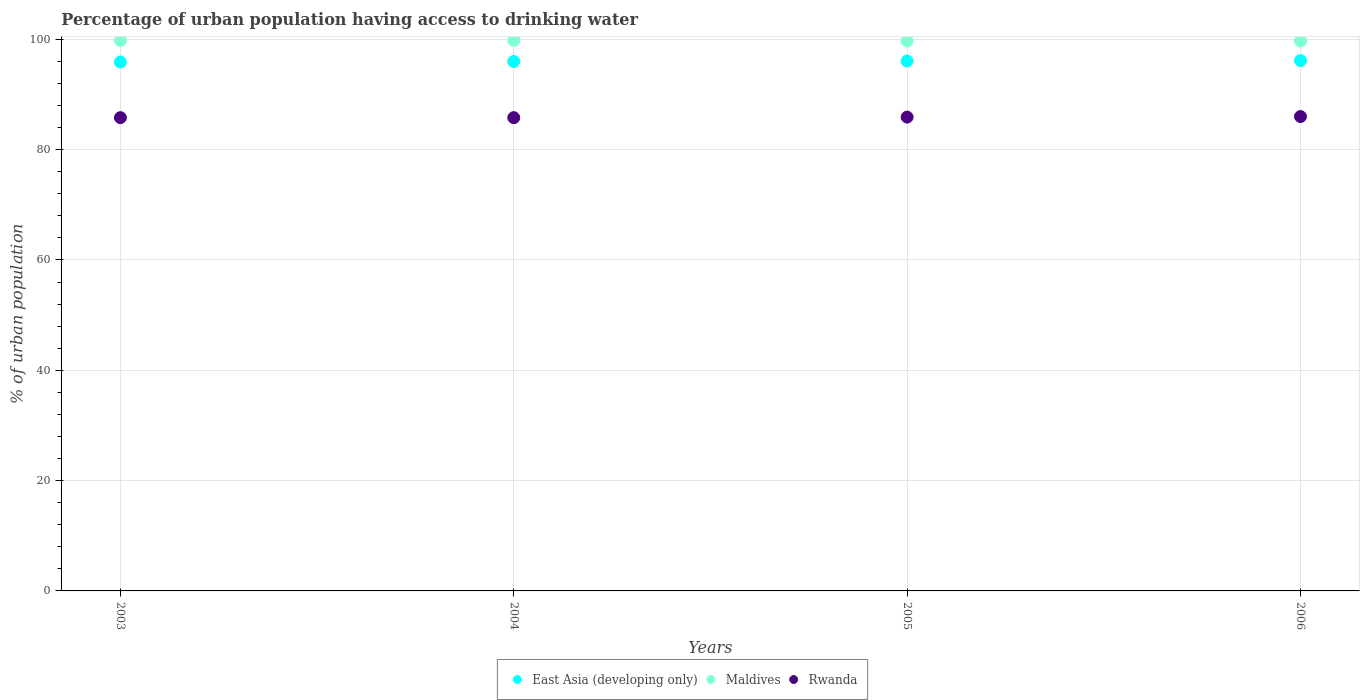What is the percentage of urban population having access to drinking water in Maldives in 2005?
Your answer should be compact. 99.7. Across all years, what is the maximum percentage of urban population having access to drinking water in Maldives?
Your response must be concise. 99.8. Across all years, what is the minimum percentage of urban population having access to drinking water in East Asia (developing only)?
Give a very brief answer. 95.9. In which year was the percentage of urban population having access to drinking water in East Asia (developing only) minimum?
Your response must be concise. 2003. What is the total percentage of urban population having access to drinking water in East Asia (developing only) in the graph?
Make the answer very short. 384.1. What is the difference between the percentage of urban population having access to drinking water in Maldives in 2004 and that in 2006?
Provide a succinct answer. 0.1. What is the difference between the percentage of urban population having access to drinking water in Rwanda in 2003 and the percentage of urban population having access to drinking water in Maldives in 2005?
Offer a terse response. -13.9. What is the average percentage of urban population having access to drinking water in Rwanda per year?
Offer a terse response. 85.88. In the year 2003, what is the difference between the percentage of urban population having access to drinking water in East Asia (developing only) and percentage of urban population having access to drinking water in Maldives?
Your response must be concise. -3.9. In how many years, is the percentage of urban population having access to drinking water in Rwanda greater than 40 %?
Offer a very short reply. 4. What is the ratio of the percentage of urban population having access to drinking water in Rwanda in 2003 to that in 2004?
Offer a very short reply. 1. Is the difference between the percentage of urban population having access to drinking water in East Asia (developing only) in 2003 and 2006 greater than the difference between the percentage of urban population having access to drinking water in Maldives in 2003 and 2006?
Provide a succinct answer. No. What is the difference between the highest and the second highest percentage of urban population having access to drinking water in East Asia (developing only)?
Provide a short and direct response. 0.08. What is the difference between the highest and the lowest percentage of urban population having access to drinking water in Rwanda?
Give a very brief answer. 0.2. Is the sum of the percentage of urban population having access to drinking water in East Asia (developing only) in 2005 and 2006 greater than the maximum percentage of urban population having access to drinking water in Maldives across all years?
Your response must be concise. Yes. Does the percentage of urban population having access to drinking water in Rwanda monotonically increase over the years?
Your answer should be compact. No. Is the percentage of urban population having access to drinking water in Maldives strictly greater than the percentage of urban population having access to drinking water in East Asia (developing only) over the years?
Keep it short and to the point. Yes. How many dotlines are there?
Offer a very short reply. 3. What is the difference between two consecutive major ticks on the Y-axis?
Your response must be concise. 20. Does the graph contain any zero values?
Your answer should be very brief. No. Where does the legend appear in the graph?
Offer a very short reply. Bottom center. What is the title of the graph?
Your answer should be very brief. Percentage of urban population having access to drinking water. Does "Venezuela" appear as one of the legend labels in the graph?
Provide a succinct answer. No. What is the label or title of the X-axis?
Give a very brief answer. Years. What is the label or title of the Y-axis?
Provide a short and direct response. % of urban population. What is the % of urban population of East Asia (developing only) in 2003?
Ensure brevity in your answer.  95.9. What is the % of urban population of Maldives in 2003?
Offer a terse response. 99.8. What is the % of urban population of Rwanda in 2003?
Offer a very short reply. 85.8. What is the % of urban population in East Asia (developing only) in 2004?
Keep it short and to the point. 95.98. What is the % of urban population in Maldives in 2004?
Provide a succinct answer. 99.8. What is the % of urban population in Rwanda in 2004?
Your answer should be very brief. 85.8. What is the % of urban population of East Asia (developing only) in 2005?
Your response must be concise. 96.07. What is the % of urban population of Maldives in 2005?
Your answer should be compact. 99.7. What is the % of urban population of Rwanda in 2005?
Give a very brief answer. 85.9. What is the % of urban population in East Asia (developing only) in 2006?
Give a very brief answer. 96.15. What is the % of urban population in Maldives in 2006?
Offer a very short reply. 99.7. Across all years, what is the maximum % of urban population in East Asia (developing only)?
Provide a succinct answer. 96.15. Across all years, what is the maximum % of urban population of Maldives?
Give a very brief answer. 99.8. Across all years, what is the maximum % of urban population of Rwanda?
Give a very brief answer. 86. Across all years, what is the minimum % of urban population of East Asia (developing only)?
Give a very brief answer. 95.9. Across all years, what is the minimum % of urban population in Maldives?
Offer a very short reply. 99.7. Across all years, what is the minimum % of urban population of Rwanda?
Give a very brief answer. 85.8. What is the total % of urban population in East Asia (developing only) in the graph?
Give a very brief answer. 384.1. What is the total % of urban population of Maldives in the graph?
Provide a short and direct response. 399. What is the total % of urban population in Rwanda in the graph?
Give a very brief answer. 343.5. What is the difference between the % of urban population of East Asia (developing only) in 2003 and that in 2004?
Your answer should be very brief. -0.09. What is the difference between the % of urban population in Maldives in 2003 and that in 2004?
Ensure brevity in your answer.  0. What is the difference between the % of urban population of Rwanda in 2003 and that in 2004?
Offer a terse response. 0. What is the difference between the % of urban population of East Asia (developing only) in 2003 and that in 2005?
Ensure brevity in your answer.  -0.17. What is the difference between the % of urban population in Rwanda in 2003 and that in 2005?
Your response must be concise. -0.1. What is the difference between the % of urban population of East Asia (developing only) in 2003 and that in 2006?
Provide a succinct answer. -0.25. What is the difference between the % of urban population in Rwanda in 2003 and that in 2006?
Ensure brevity in your answer.  -0.2. What is the difference between the % of urban population in East Asia (developing only) in 2004 and that in 2005?
Your response must be concise. -0.08. What is the difference between the % of urban population of Rwanda in 2004 and that in 2005?
Your response must be concise. -0.1. What is the difference between the % of urban population of East Asia (developing only) in 2004 and that in 2006?
Your answer should be compact. -0.16. What is the difference between the % of urban population of East Asia (developing only) in 2005 and that in 2006?
Provide a short and direct response. -0.08. What is the difference between the % of urban population of Maldives in 2005 and that in 2006?
Offer a very short reply. 0. What is the difference between the % of urban population of East Asia (developing only) in 2003 and the % of urban population of Maldives in 2004?
Ensure brevity in your answer.  -3.9. What is the difference between the % of urban population of East Asia (developing only) in 2003 and the % of urban population of Rwanda in 2004?
Give a very brief answer. 10.1. What is the difference between the % of urban population in East Asia (developing only) in 2003 and the % of urban population in Maldives in 2005?
Make the answer very short. -3.8. What is the difference between the % of urban population in East Asia (developing only) in 2003 and the % of urban population in Rwanda in 2005?
Keep it short and to the point. 10. What is the difference between the % of urban population in East Asia (developing only) in 2003 and the % of urban population in Maldives in 2006?
Give a very brief answer. -3.8. What is the difference between the % of urban population of East Asia (developing only) in 2003 and the % of urban population of Rwanda in 2006?
Your response must be concise. 9.9. What is the difference between the % of urban population of Maldives in 2003 and the % of urban population of Rwanda in 2006?
Offer a terse response. 13.8. What is the difference between the % of urban population in East Asia (developing only) in 2004 and the % of urban population in Maldives in 2005?
Your response must be concise. -3.72. What is the difference between the % of urban population in East Asia (developing only) in 2004 and the % of urban population in Rwanda in 2005?
Offer a terse response. 10.08. What is the difference between the % of urban population of East Asia (developing only) in 2004 and the % of urban population of Maldives in 2006?
Offer a terse response. -3.72. What is the difference between the % of urban population of East Asia (developing only) in 2004 and the % of urban population of Rwanda in 2006?
Make the answer very short. 9.98. What is the difference between the % of urban population of East Asia (developing only) in 2005 and the % of urban population of Maldives in 2006?
Ensure brevity in your answer.  -3.63. What is the difference between the % of urban population in East Asia (developing only) in 2005 and the % of urban population in Rwanda in 2006?
Give a very brief answer. 10.07. What is the difference between the % of urban population of Maldives in 2005 and the % of urban population of Rwanda in 2006?
Keep it short and to the point. 13.7. What is the average % of urban population of East Asia (developing only) per year?
Provide a short and direct response. 96.03. What is the average % of urban population in Maldives per year?
Your response must be concise. 99.75. What is the average % of urban population in Rwanda per year?
Your answer should be very brief. 85.88. In the year 2003, what is the difference between the % of urban population of East Asia (developing only) and % of urban population of Maldives?
Offer a very short reply. -3.9. In the year 2003, what is the difference between the % of urban population in East Asia (developing only) and % of urban population in Rwanda?
Offer a terse response. 10.1. In the year 2003, what is the difference between the % of urban population in Maldives and % of urban population in Rwanda?
Keep it short and to the point. 14. In the year 2004, what is the difference between the % of urban population in East Asia (developing only) and % of urban population in Maldives?
Your response must be concise. -3.82. In the year 2004, what is the difference between the % of urban population of East Asia (developing only) and % of urban population of Rwanda?
Offer a very short reply. 10.18. In the year 2005, what is the difference between the % of urban population in East Asia (developing only) and % of urban population in Maldives?
Your answer should be compact. -3.63. In the year 2005, what is the difference between the % of urban population of East Asia (developing only) and % of urban population of Rwanda?
Your answer should be very brief. 10.17. In the year 2006, what is the difference between the % of urban population in East Asia (developing only) and % of urban population in Maldives?
Give a very brief answer. -3.55. In the year 2006, what is the difference between the % of urban population in East Asia (developing only) and % of urban population in Rwanda?
Give a very brief answer. 10.15. In the year 2006, what is the difference between the % of urban population in Maldives and % of urban population in Rwanda?
Your response must be concise. 13.7. What is the ratio of the % of urban population in East Asia (developing only) in 2003 to that in 2004?
Offer a terse response. 1. What is the ratio of the % of urban population of East Asia (developing only) in 2003 to that in 2005?
Make the answer very short. 1. What is the ratio of the % of urban population in Rwanda in 2003 to that in 2005?
Make the answer very short. 1. What is the ratio of the % of urban population in Maldives in 2003 to that in 2006?
Your answer should be very brief. 1. What is the ratio of the % of urban population of Maldives in 2004 to that in 2005?
Ensure brevity in your answer.  1. What is the ratio of the % of urban population of Rwanda in 2004 to that in 2005?
Offer a terse response. 1. What is the ratio of the % of urban population of East Asia (developing only) in 2004 to that in 2006?
Ensure brevity in your answer.  1. What is the ratio of the % of urban population of Maldives in 2004 to that in 2006?
Keep it short and to the point. 1. What is the ratio of the % of urban population of East Asia (developing only) in 2005 to that in 2006?
Your answer should be very brief. 1. What is the ratio of the % of urban population in Rwanda in 2005 to that in 2006?
Provide a succinct answer. 1. What is the difference between the highest and the second highest % of urban population in East Asia (developing only)?
Your response must be concise. 0.08. What is the difference between the highest and the second highest % of urban population in Rwanda?
Give a very brief answer. 0.1. What is the difference between the highest and the lowest % of urban population in East Asia (developing only)?
Offer a very short reply. 0.25. 